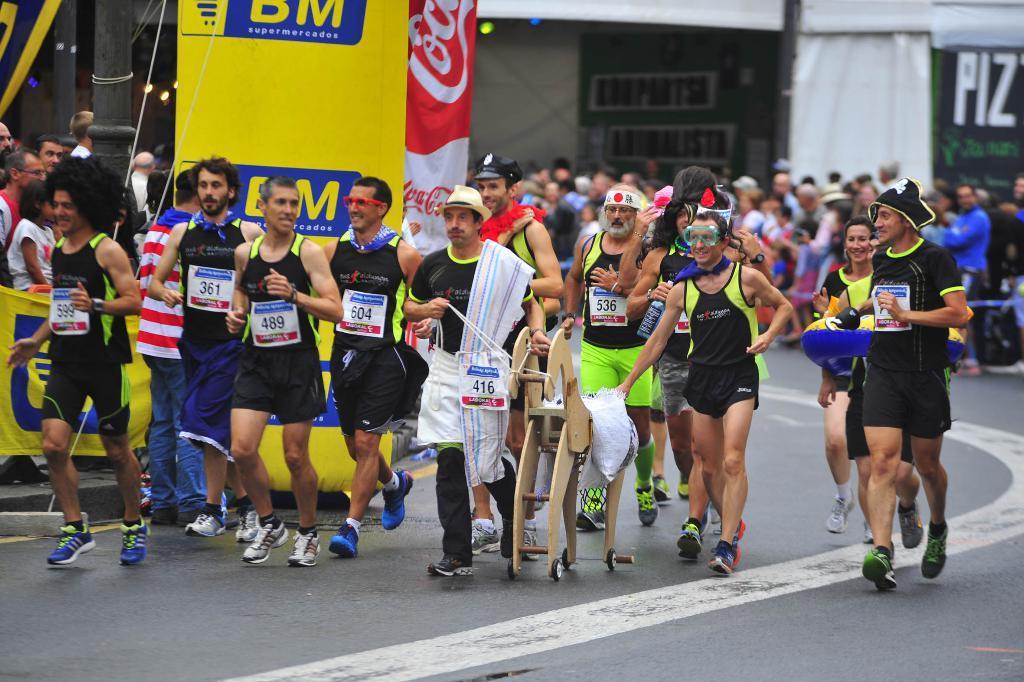Could you give a brief overview of what you see in this image? In this image we can see group of persons wearing dress are standing on the ground. One person is holding a doll with his hand placed on the ground. In the background, we can see banners with text, sheds, poles and some lights. 